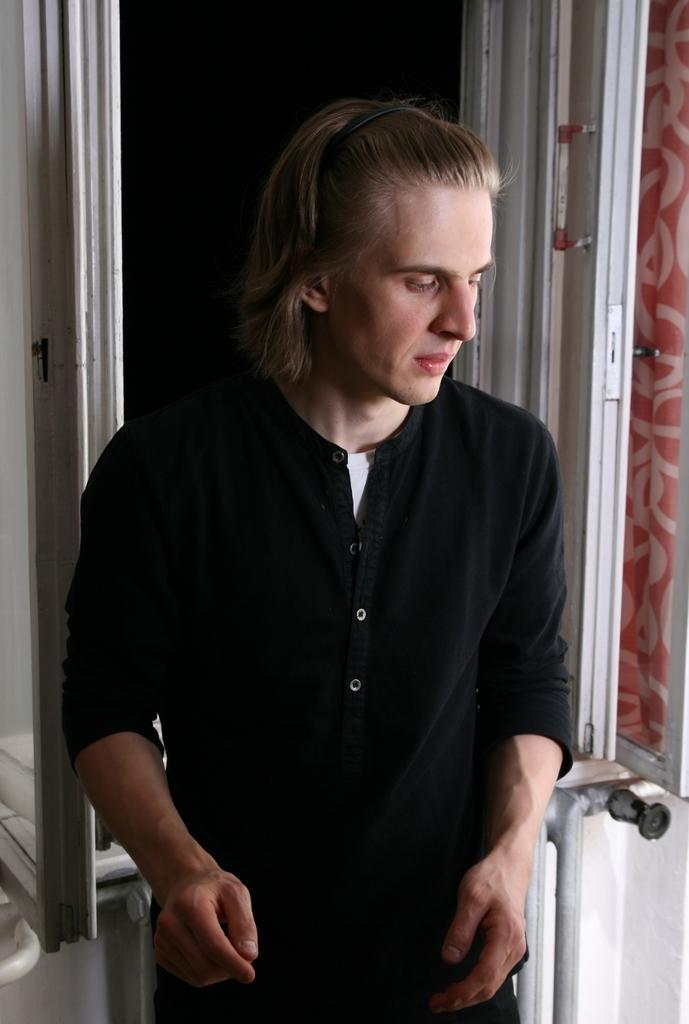How would you summarize this image in a sentence or two? In this picture we can see a person and at the back of this person we can see the wall, cloth, some objects and in the background it is dark. 